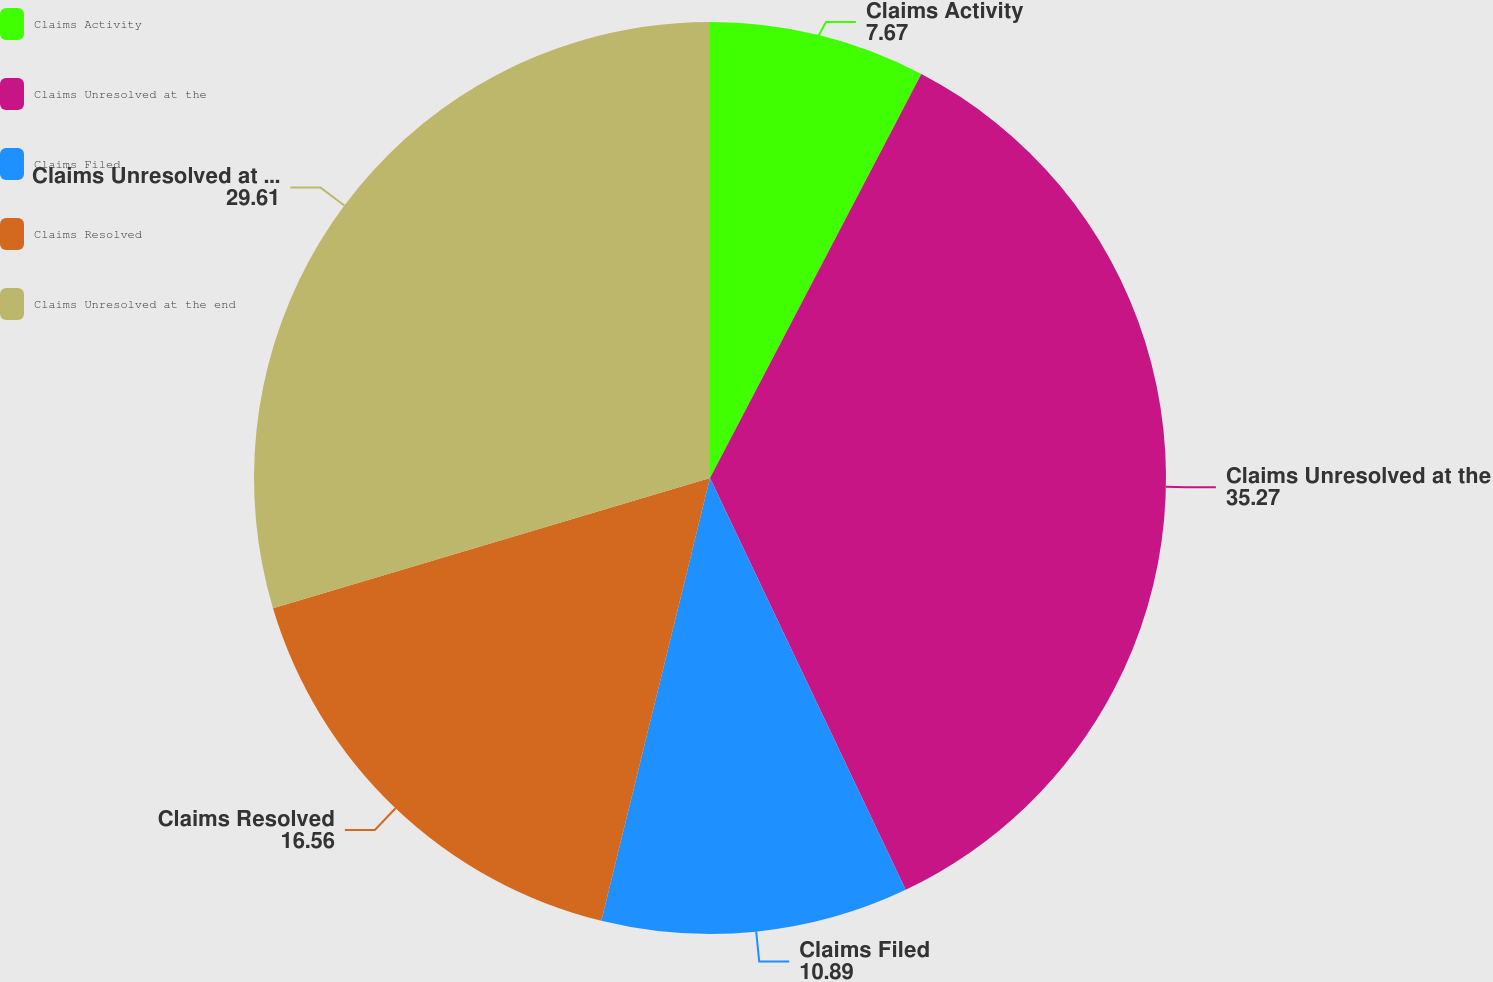Convert chart to OTSL. <chart><loc_0><loc_0><loc_500><loc_500><pie_chart><fcel>Claims Activity<fcel>Claims Unresolved at the<fcel>Claims Filed<fcel>Claims Resolved<fcel>Claims Unresolved at the end<nl><fcel>7.67%<fcel>35.27%<fcel>10.89%<fcel>16.56%<fcel>29.61%<nl></chart> 